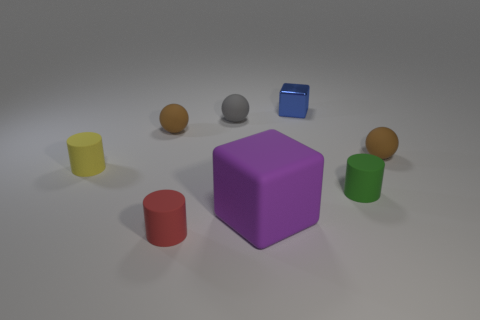The small metal object has what color?
Give a very brief answer. Blue. There is a brown matte object that is left of the tiny brown matte ball on the right side of the brown object on the left side of the tiny red rubber object; what size is it?
Your answer should be compact. Small. What number of other things are the same size as the yellow matte object?
Ensure brevity in your answer.  6. How many big gray objects are the same material as the tiny gray thing?
Keep it short and to the point. 0. What shape is the small thing behind the tiny gray sphere?
Offer a terse response. Cube. Is the tiny red cylinder made of the same material as the brown sphere that is to the left of the large rubber cube?
Your answer should be very brief. Yes. Is there a tiny brown metal sphere?
Provide a short and direct response. No. Are there any green objects in front of the brown ball in front of the brown ball left of the small gray sphere?
Your response must be concise. Yes. How many big objects are purple rubber spheres or metallic things?
Offer a very short reply. 0. There is a metallic cube that is the same size as the yellow rubber cylinder; what color is it?
Offer a terse response. Blue. 